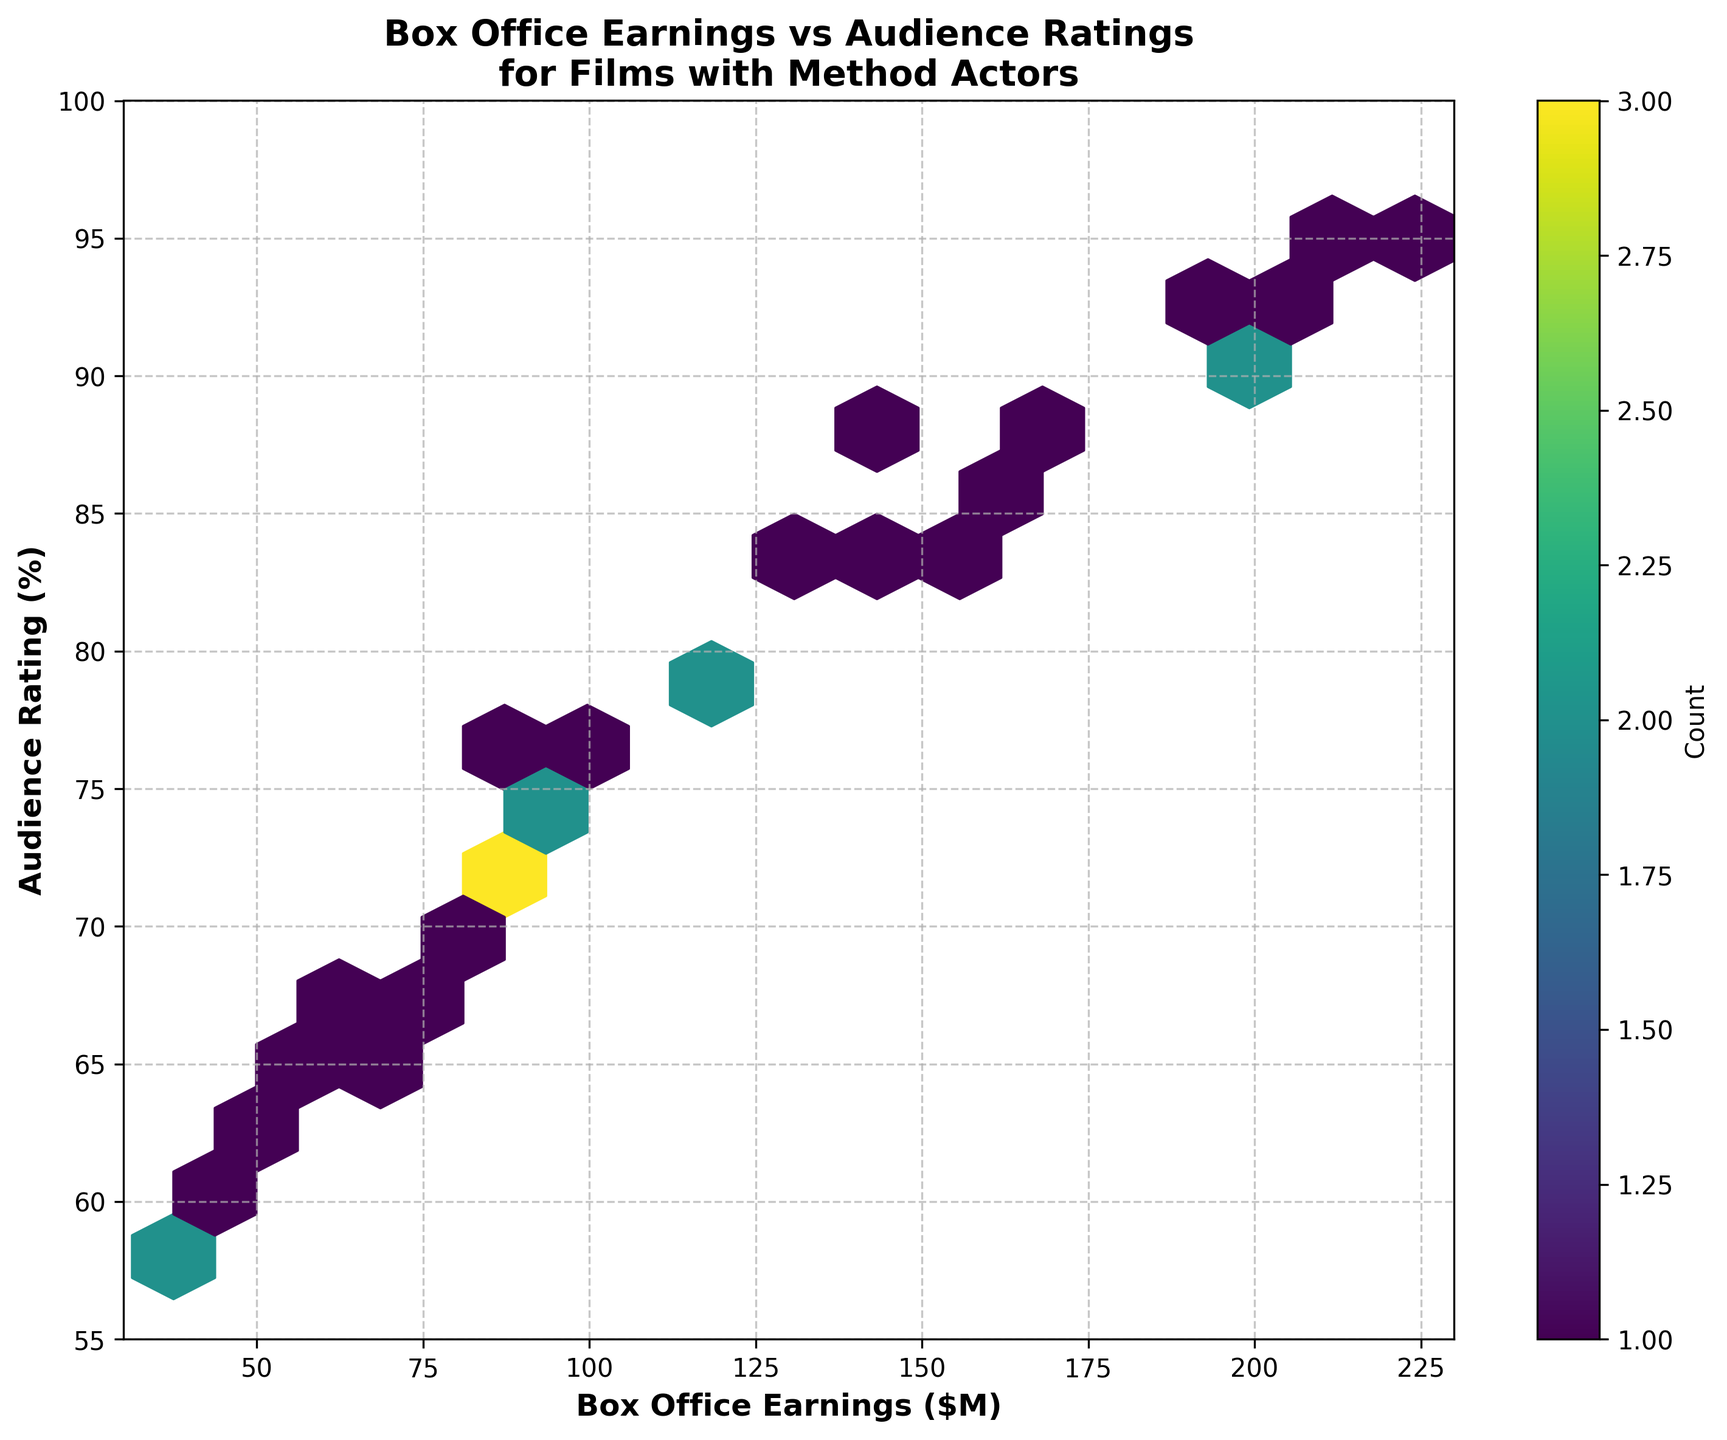What's the title of the plot? The title of the plot is usually found at the top of the figure. For this plot, it reads "Box Office Earnings vs Audience Ratings for Films with Method Actors."
Answer: Box Office Earnings vs Audience Ratings for Films with Method Actors What is the range of the Box Office Earnings axis? The range of the Box Office Earnings axis is determined by the labeled values along the x-axis. In this plot, it ranges from $30M to $230M.
Answer: 30 to 230 How many hexagons have the highest count? The color bar to the right of the plot indicates the count in the hexagons. The darkest color represents the highest count, and we need to count how many hexagons have this color. In this plot, there are 2 hexagons with the highest count.
Answer: 2 What's the most common range of audience ratings for films with box office earnings between $100M and $150M? Look at the hexagons between $100M and $150M on the x-axis and identify the range of audience ratings (y-axis) where the highest concentration (darker color) occurs. The most common range is between 75% and 85%.
Answer: 75% to 85% Are there more films rated above 80% or below 70%? Count the hexagons above and below these thresholds on the y-axis. There are more films rated above 80% because there are darker hexagons (more frequent occurrence) above this threshold than below 70%.
Answer: Above 80% What's the average box office earnings for the films with the highest audience ratings? Identify the hexagons in the range of the highest audience ratings (90% to 95%) and note their positions along the x-axis. The average box office earnings can be calculated by averaging the earnings represented by these hexagons: (201.3 + 189.5 + 224.1 + 215.8 + 196.2 + 208.6) / 6 = 205.9
Answer: 205.9 Which box office earnings bracket has the largest spread of audience ratings? Observe the width of the spread of audience ratings for different segments of the x-axis (box office earnings). The earnings bracket between $60M and $110M shows the largest spread, ranging from about 55% to 80%.
Answer: $60M to $110M Do higher box office earnings generally correspond to higher audience ratings? In general, the plot shows that hexagons representing higher box office earnings (right side of the plot) tend to have higher audience ratings (upper side of the plot), suggesting a positive correlation between the two variables.
Answer: Yes Which section has the most dense clustering of hexagons? The densest clustering of hexagons is indicated by the darkest area of the plot. This is found in the section where box office earnings are around $60M to $120M, and audience ratings are between 65% and 80%.
Answer: $60M to $120M, 65% to 80% Do any hexagons along the x-axis indicate a very low audience rating, below 60%? Scan the hexagons along the x-axis for any parts that dip below 60% on the y-axis. There are a few hexagons indicating ratings below 60%, particularly for lower earnings around $40M to $50M.
Answer: Yes 